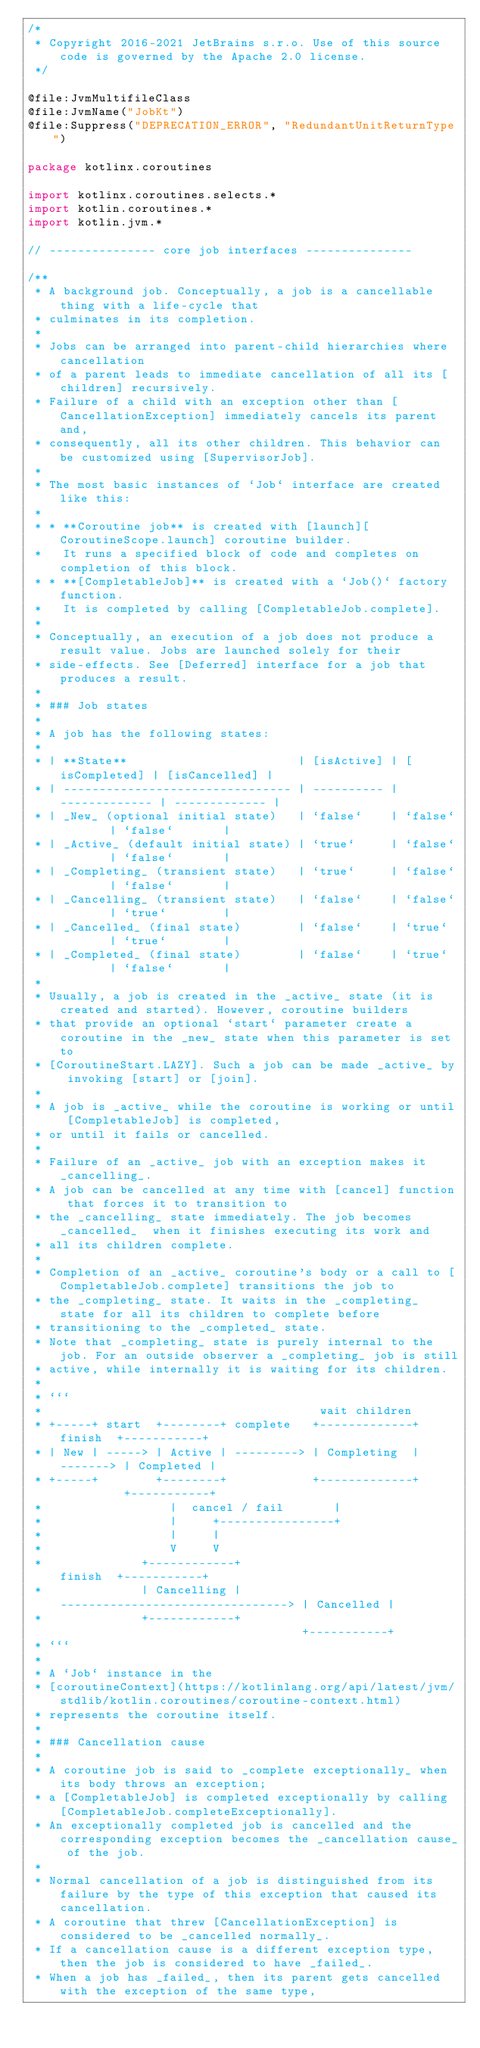Convert code to text. <code><loc_0><loc_0><loc_500><loc_500><_Kotlin_>/*
 * Copyright 2016-2021 JetBrains s.r.o. Use of this source code is governed by the Apache 2.0 license.
 */

@file:JvmMultifileClass
@file:JvmName("JobKt")
@file:Suppress("DEPRECATION_ERROR", "RedundantUnitReturnType")

package kotlinx.coroutines

import kotlinx.coroutines.selects.*
import kotlin.coroutines.*
import kotlin.jvm.*

// --------------- core job interfaces ---------------

/**
 * A background job. Conceptually, a job is a cancellable thing with a life-cycle that
 * culminates in its completion.
 *
 * Jobs can be arranged into parent-child hierarchies where cancellation
 * of a parent leads to immediate cancellation of all its [children] recursively.
 * Failure of a child with an exception other than [CancellationException] immediately cancels its parent and,
 * consequently, all its other children. This behavior can be customized using [SupervisorJob].
 *
 * The most basic instances of `Job` interface are created like this:
 *
 * * **Coroutine job** is created with [launch][CoroutineScope.launch] coroutine builder.
 *   It runs a specified block of code and completes on completion of this block.
 * * **[CompletableJob]** is created with a `Job()` factory function.
 *   It is completed by calling [CompletableJob.complete].
 *
 * Conceptually, an execution of a job does not produce a result value. Jobs are launched solely for their
 * side-effects. See [Deferred] interface for a job that produces a result.
 *
 * ### Job states
 *
 * A job has the following states:
 *
 * | **State**                        | [isActive] | [isCompleted] | [isCancelled] |
 * | -------------------------------- | ---------- | ------------- | ------------- |
 * | _New_ (optional initial state)   | `false`    | `false`       | `false`       |
 * | _Active_ (default initial state) | `true`     | `false`       | `false`       |
 * | _Completing_ (transient state)   | `true`     | `false`       | `false`       |
 * | _Cancelling_ (transient state)   | `false`    | `false`       | `true`        |
 * | _Cancelled_ (final state)        | `false`    | `true`        | `true`        |
 * | _Completed_ (final state)        | `false`    | `true`        | `false`       |
 *
 * Usually, a job is created in the _active_ state (it is created and started). However, coroutine builders
 * that provide an optional `start` parameter create a coroutine in the _new_ state when this parameter is set to
 * [CoroutineStart.LAZY]. Such a job can be made _active_ by invoking [start] or [join].
 *
 * A job is _active_ while the coroutine is working or until [CompletableJob] is completed,
 * or until it fails or cancelled.
 *
 * Failure of an _active_ job with an exception makes it _cancelling_.
 * A job can be cancelled at any time with [cancel] function that forces it to transition to
 * the _cancelling_ state immediately. The job becomes _cancelled_  when it finishes executing its work and
 * all its children complete.
 *
 * Completion of an _active_ coroutine's body or a call to [CompletableJob.complete] transitions the job to
 * the _completing_ state. It waits in the _completing_ state for all its children to complete before
 * transitioning to the _completed_ state.
 * Note that _completing_ state is purely internal to the job. For an outside observer a _completing_ job is still
 * active, while internally it is waiting for its children.
 *
 * ```
 *                                       wait children
 * +-----+ start  +--------+ complete   +-------------+  finish  +-----------+
 * | New | -----> | Active | ---------> | Completing  | -------> | Completed |
 * +-----+        +--------+            +-------------+          +-----------+
 *                  |  cancel / fail       |
 *                  |     +----------------+
 *                  |     |
 *                  V     V
 *              +------------+                           finish  +-----------+
 *              | Cancelling | --------------------------------> | Cancelled |
 *              +------------+                                   +-----------+
 * ```
 *
 * A `Job` instance in the
 * [coroutineContext](https://kotlinlang.org/api/latest/jvm/stdlib/kotlin.coroutines/coroutine-context.html)
 * represents the coroutine itself.
 *
 * ### Cancellation cause
 *
 * A coroutine job is said to _complete exceptionally_ when its body throws an exception;
 * a [CompletableJob] is completed exceptionally by calling [CompletableJob.completeExceptionally].
 * An exceptionally completed job is cancelled and the corresponding exception becomes the _cancellation cause_ of the job.
 *
 * Normal cancellation of a job is distinguished from its failure by the type of this exception that caused its cancellation.
 * A coroutine that threw [CancellationException] is considered to be _cancelled normally_.
 * If a cancellation cause is a different exception type, then the job is considered to have _failed_.
 * When a job has _failed_, then its parent gets cancelled with the exception of the same type,</code> 